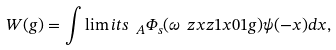<formula> <loc_0><loc_0><loc_500><loc_500>W ( g ) = \int \lim i t s _ { \ A } \Phi _ { s } ( \omega \ z x z { 1 } { x } { 0 } { 1 } g ) \psi ( - x ) d x ,</formula> 